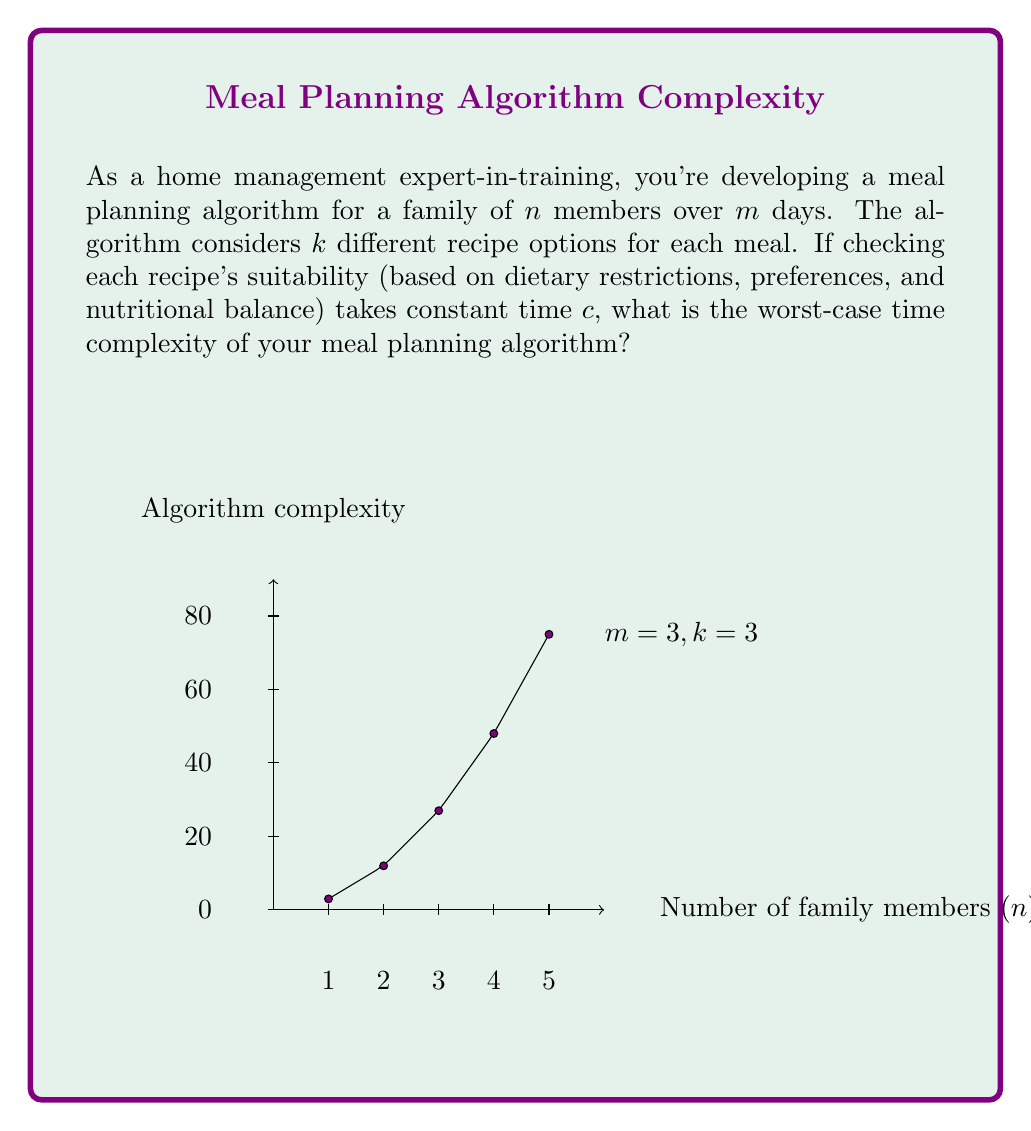Help me with this question. Let's approach this step-by-step:

1) For each day, we need to plan 3 meals (breakfast, lunch, dinner).

2) For each meal, we have $k$ recipe options to consider.

3) We need to do this for $m$ days.

4) For each recipe, we need to check its suitability for all $n$ family members.

5) Checking each recipe's suitability takes constant time $c$.

Therefore, the total number of operations is:

$$ m \cdot 3 \cdot k \cdot n \cdot c $$

Breaking this down:
- $m$ for the number of days
- 3 for the number of meals per day
- $k$ for the number of recipe options per meal
- $n$ for the number of family members to check for
- $c$ for the constant time to check each recipe's suitability

6) In big O notation, we drop constants and lower-order terms. So, $3$ and $c$ can be removed.

7) This leaves us with $O(mkn)$.

This represents the worst-case scenario where we need to check every recipe option for every meal for every day for every family member.
Answer: $O(mkn)$ 